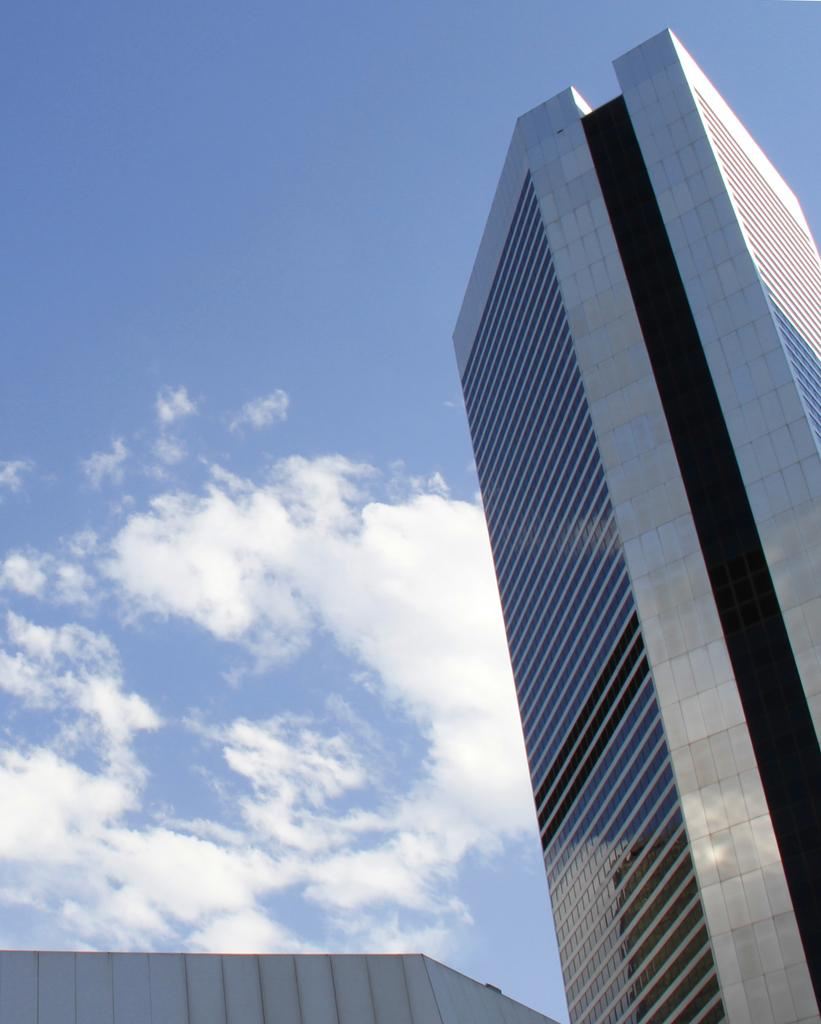What type of structure is visible in the image? There is a tall building in the image. What can be seen in the sky in the background of the image? There are clouds in the sky in the background of the image. What type of record is being played in the image? There is no record present in the image; it only features a tall building and clouds in the sky. 